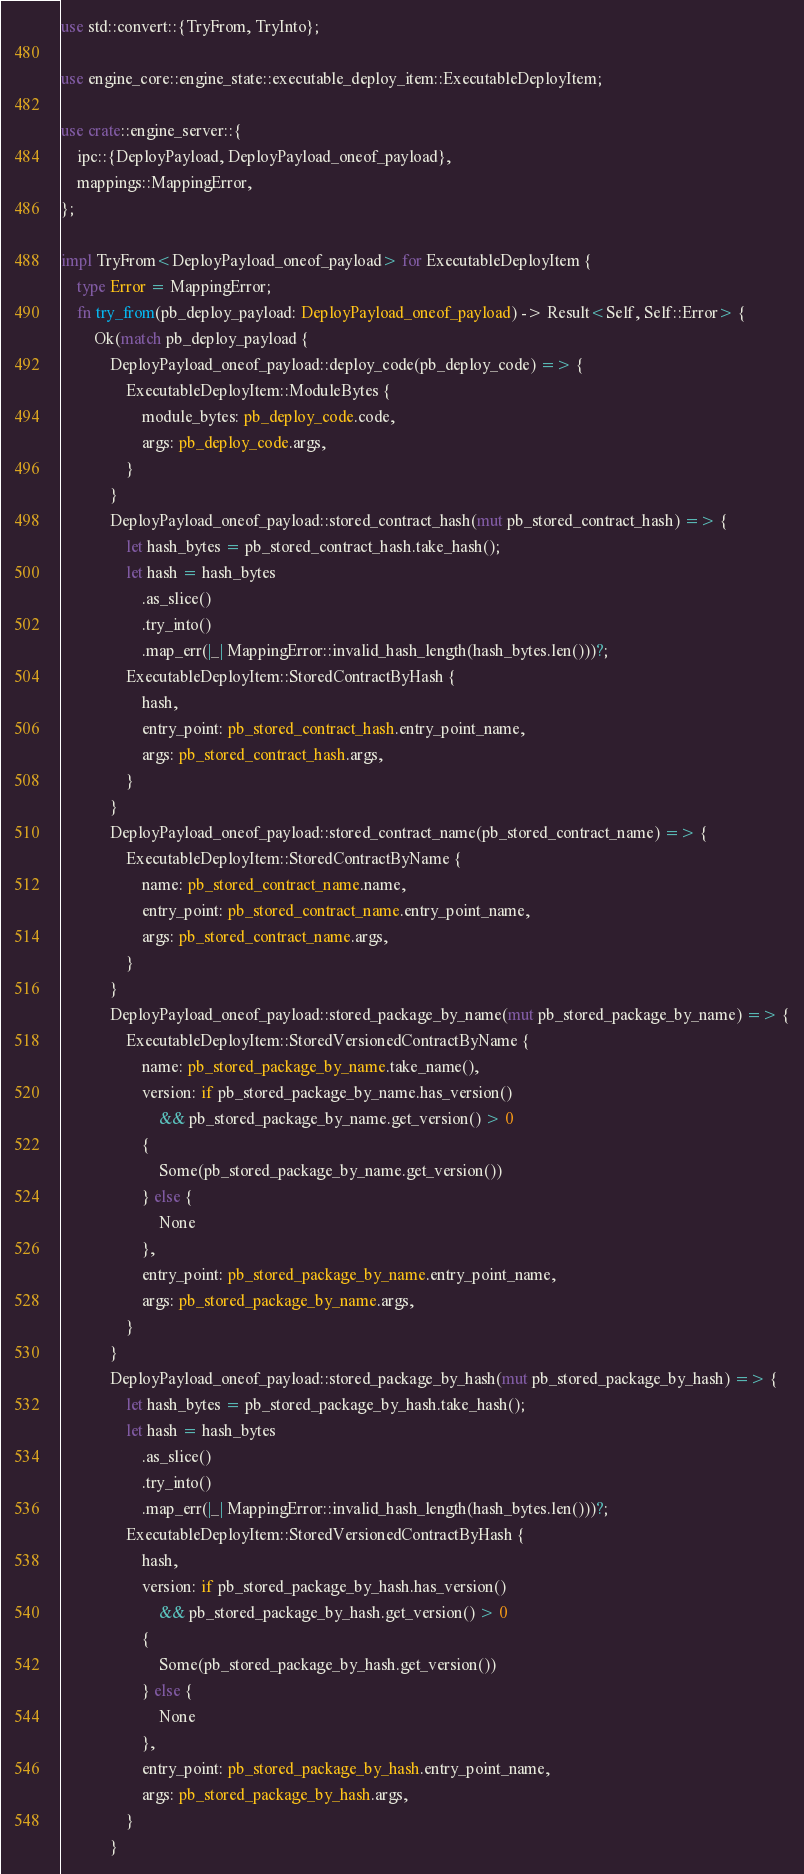<code> <loc_0><loc_0><loc_500><loc_500><_Rust_>use std::convert::{TryFrom, TryInto};

use engine_core::engine_state::executable_deploy_item::ExecutableDeployItem;

use crate::engine_server::{
    ipc::{DeployPayload, DeployPayload_oneof_payload},
    mappings::MappingError,
};

impl TryFrom<DeployPayload_oneof_payload> for ExecutableDeployItem {
    type Error = MappingError;
    fn try_from(pb_deploy_payload: DeployPayload_oneof_payload) -> Result<Self, Self::Error> {
        Ok(match pb_deploy_payload {
            DeployPayload_oneof_payload::deploy_code(pb_deploy_code) => {
                ExecutableDeployItem::ModuleBytes {
                    module_bytes: pb_deploy_code.code,
                    args: pb_deploy_code.args,
                }
            }
            DeployPayload_oneof_payload::stored_contract_hash(mut pb_stored_contract_hash) => {
                let hash_bytes = pb_stored_contract_hash.take_hash();
                let hash = hash_bytes
                    .as_slice()
                    .try_into()
                    .map_err(|_| MappingError::invalid_hash_length(hash_bytes.len()))?;
                ExecutableDeployItem::StoredContractByHash {
                    hash,
                    entry_point: pb_stored_contract_hash.entry_point_name,
                    args: pb_stored_contract_hash.args,
                }
            }
            DeployPayload_oneof_payload::stored_contract_name(pb_stored_contract_name) => {
                ExecutableDeployItem::StoredContractByName {
                    name: pb_stored_contract_name.name,
                    entry_point: pb_stored_contract_name.entry_point_name,
                    args: pb_stored_contract_name.args,
                }
            }
            DeployPayload_oneof_payload::stored_package_by_name(mut pb_stored_package_by_name) => {
                ExecutableDeployItem::StoredVersionedContractByName {
                    name: pb_stored_package_by_name.take_name(),
                    version: if pb_stored_package_by_name.has_version()
                        && pb_stored_package_by_name.get_version() > 0
                    {
                        Some(pb_stored_package_by_name.get_version())
                    } else {
                        None
                    },
                    entry_point: pb_stored_package_by_name.entry_point_name,
                    args: pb_stored_package_by_name.args,
                }
            }
            DeployPayload_oneof_payload::stored_package_by_hash(mut pb_stored_package_by_hash) => {
                let hash_bytes = pb_stored_package_by_hash.take_hash();
                let hash = hash_bytes
                    .as_slice()
                    .try_into()
                    .map_err(|_| MappingError::invalid_hash_length(hash_bytes.len()))?;
                ExecutableDeployItem::StoredVersionedContractByHash {
                    hash,
                    version: if pb_stored_package_by_hash.has_version()
                        && pb_stored_package_by_hash.get_version() > 0
                    {
                        Some(pb_stored_package_by_hash.get_version())
                    } else {
                        None
                    },
                    entry_point: pb_stored_package_by_hash.entry_point_name,
                    args: pb_stored_package_by_hash.args,
                }
            }</code> 